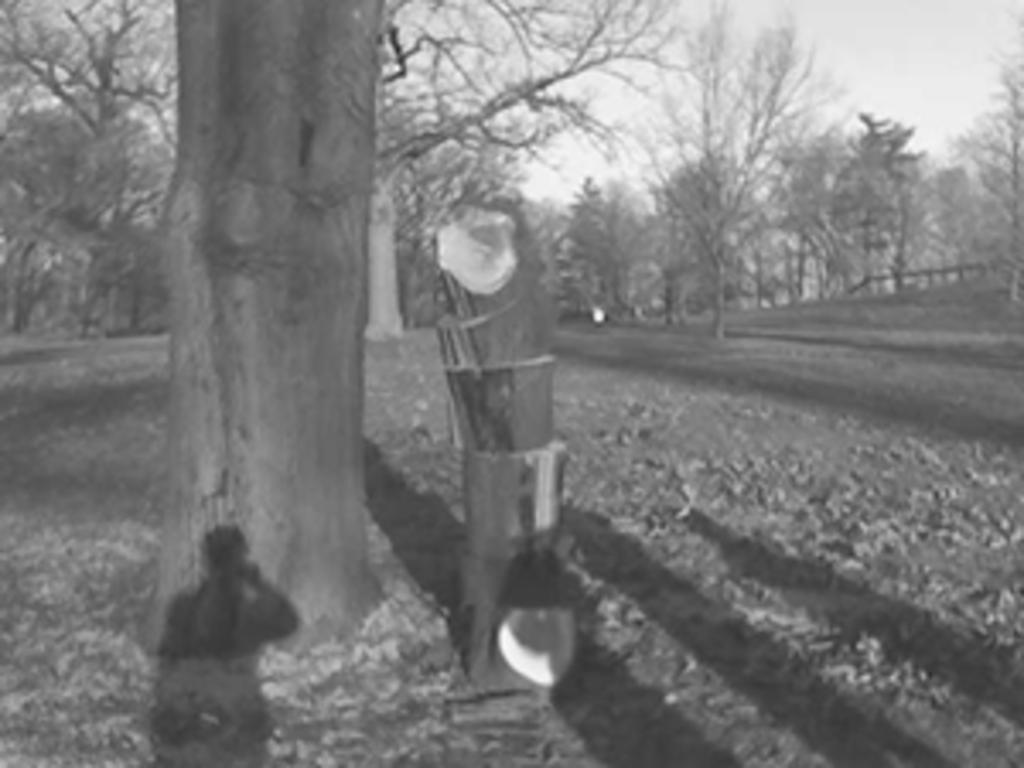What is the color scheme of the image? The image is black and white. What type of scene is depicted in the image? The image depicts an outside view. What can be seen in the foreground of the image? There is a tree stem in the foreground of the image. What is visible in the background of the image? There are trees in the background of the image. Where is the queen sitting in the image? There is no queen present in the image; it is a black and white outside view with a tree stem in the foreground and trees in the background. What type of glue is being used to hold the tree stem in the image? There is no glue present in the image; the tree stem is a natural part of the scene. 